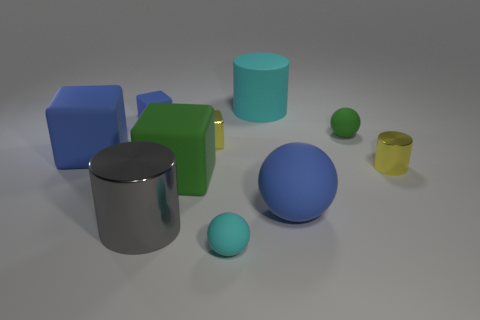Subtract all small cylinders. How many cylinders are left? 2 Subtract all cyan spheres. How many spheres are left? 2 Subtract 3 balls. How many balls are left? 0 Subtract all cylinders. How many objects are left? 7 Subtract all gray cylinders. How many blue cubes are left? 2 Subtract all yellow cylinders. Subtract all yellow shiny cylinders. How many objects are left? 8 Add 6 rubber cylinders. How many rubber cylinders are left? 7 Add 3 blue objects. How many blue objects exist? 6 Subtract 0 brown spheres. How many objects are left? 10 Subtract all yellow cubes. Subtract all gray cylinders. How many cubes are left? 3 